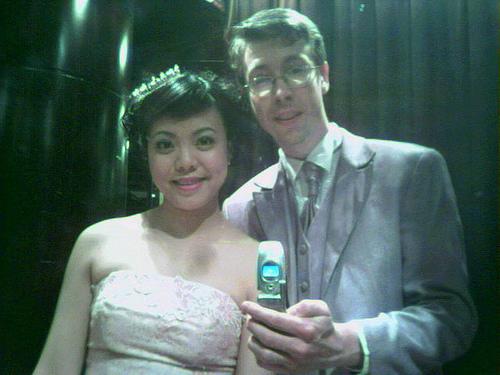Is that a clamshell phone?
Give a very brief answer. Yes. How many people are in the image?
Be succinct. 2. Is this woman married to the guy on the right?
Give a very brief answer. Yes. Is one of them wearing glasses?
Short answer required. Yes. 